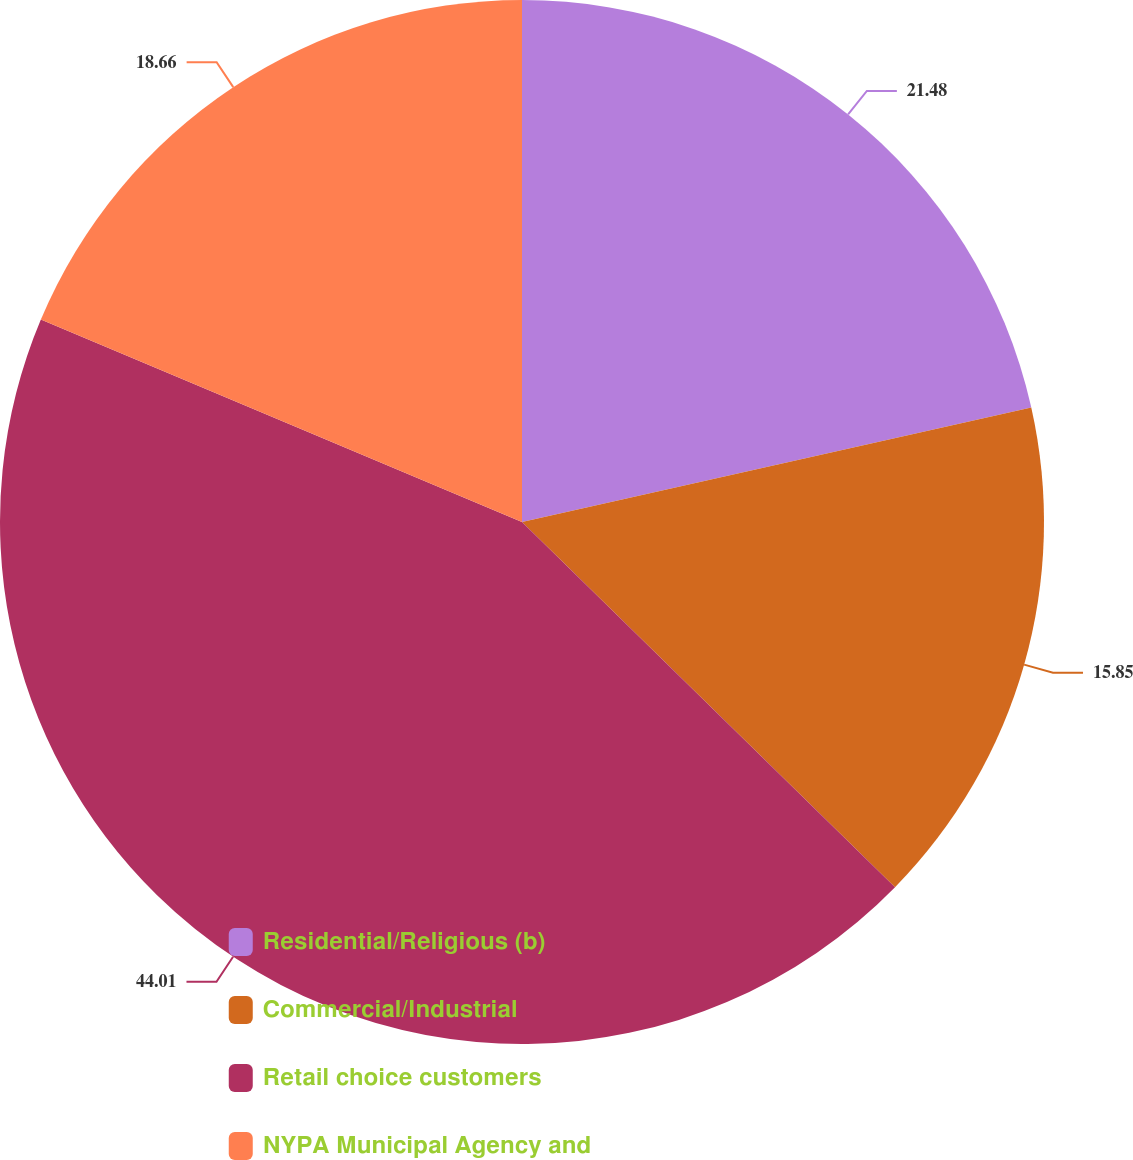Convert chart to OTSL. <chart><loc_0><loc_0><loc_500><loc_500><pie_chart><fcel>Residential/Religious (b)<fcel>Commercial/Industrial<fcel>Retail choice customers<fcel>NYPA Municipal Agency and<nl><fcel>21.48%<fcel>15.85%<fcel>44.01%<fcel>18.66%<nl></chart> 